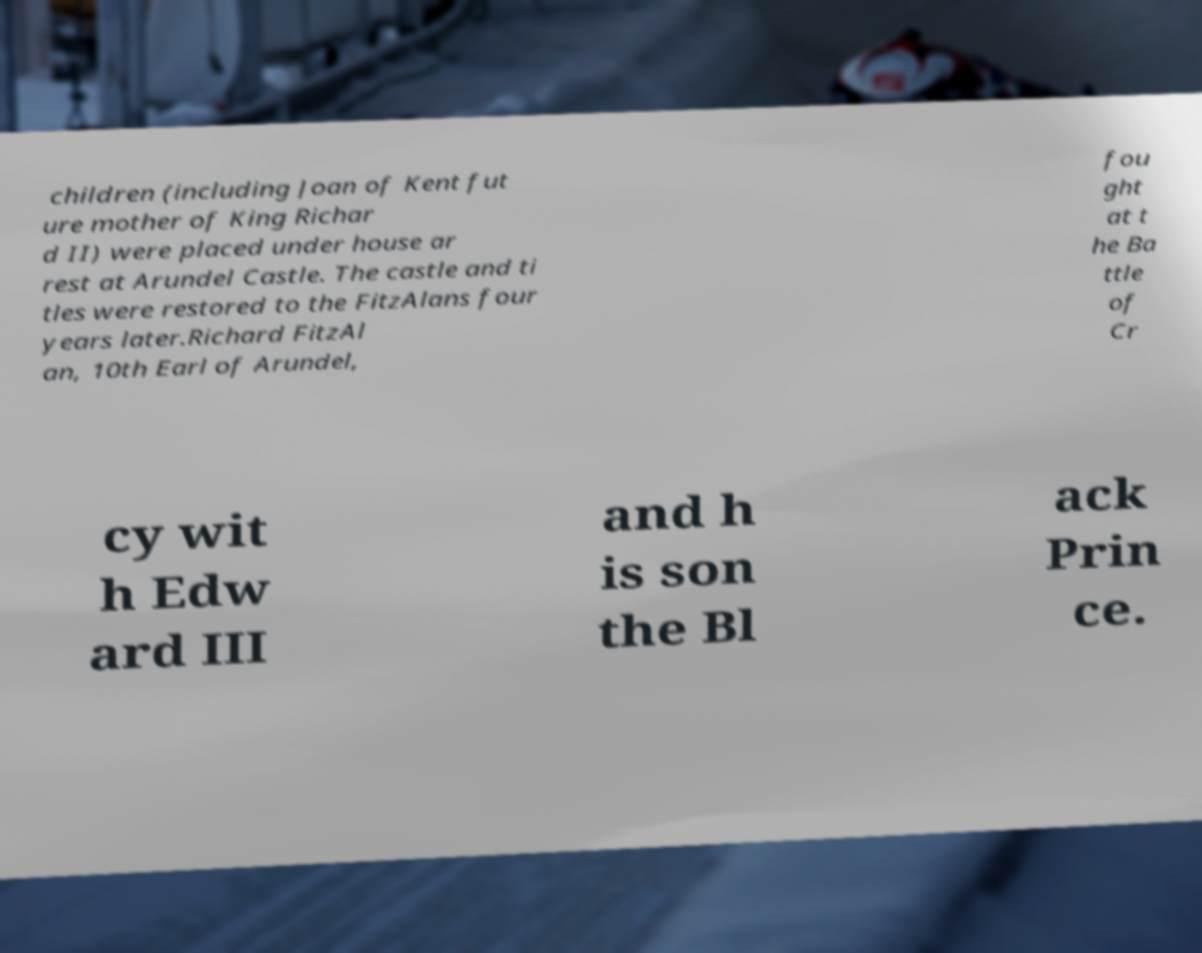There's text embedded in this image that I need extracted. Can you transcribe it verbatim? children (including Joan of Kent fut ure mother of King Richar d II) were placed under house ar rest at Arundel Castle. The castle and ti tles were restored to the FitzAlans four years later.Richard FitzAl an, 10th Earl of Arundel, fou ght at t he Ba ttle of Cr cy wit h Edw ard III and h is son the Bl ack Prin ce. 